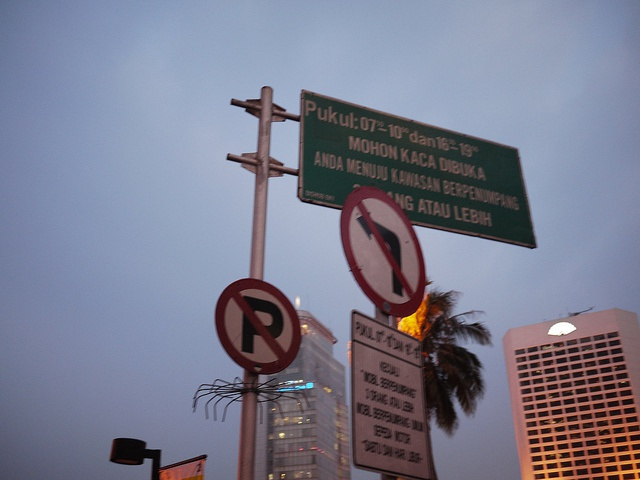Describe the objects in this image and their specific colors. I can see various objects in this image with different colors. 